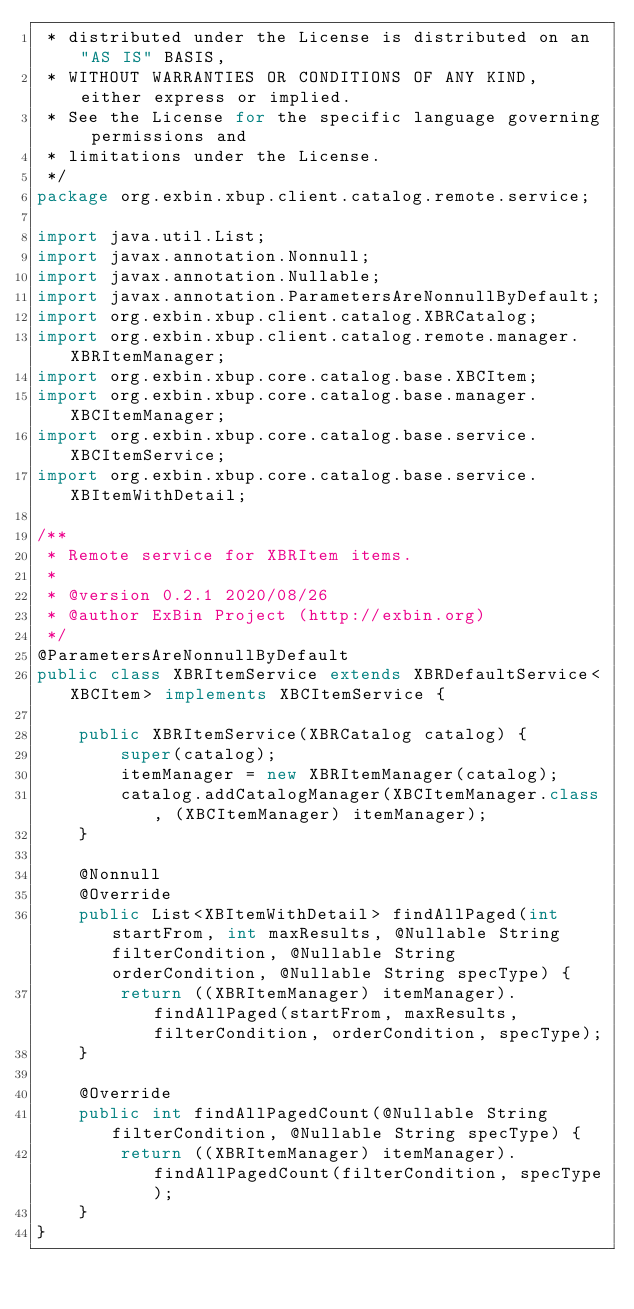<code> <loc_0><loc_0><loc_500><loc_500><_Java_> * distributed under the License is distributed on an "AS IS" BASIS,
 * WITHOUT WARRANTIES OR CONDITIONS OF ANY KIND, either express or implied.
 * See the License for the specific language governing permissions and
 * limitations under the License.
 */
package org.exbin.xbup.client.catalog.remote.service;

import java.util.List;
import javax.annotation.Nonnull;
import javax.annotation.Nullable;
import javax.annotation.ParametersAreNonnullByDefault;
import org.exbin.xbup.client.catalog.XBRCatalog;
import org.exbin.xbup.client.catalog.remote.manager.XBRItemManager;
import org.exbin.xbup.core.catalog.base.XBCItem;
import org.exbin.xbup.core.catalog.base.manager.XBCItemManager;
import org.exbin.xbup.core.catalog.base.service.XBCItemService;
import org.exbin.xbup.core.catalog.base.service.XBItemWithDetail;

/**
 * Remote service for XBRItem items.
 *
 * @version 0.2.1 2020/08/26
 * @author ExBin Project (http://exbin.org)
 */
@ParametersAreNonnullByDefault
public class XBRItemService extends XBRDefaultService<XBCItem> implements XBCItemService {

    public XBRItemService(XBRCatalog catalog) {
        super(catalog);
        itemManager = new XBRItemManager(catalog);
        catalog.addCatalogManager(XBCItemManager.class, (XBCItemManager) itemManager);
    }

    @Nonnull
    @Override
    public List<XBItemWithDetail> findAllPaged(int startFrom, int maxResults, @Nullable String filterCondition, @Nullable String orderCondition, @Nullable String specType) {
        return ((XBRItemManager) itemManager).findAllPaged(startFrom, maxResults, filterCondition, orderCondition, specType);
    }

    @Override
    public int findAllPagedCount(@Nullable String filterCondition, @Nullable String specType) {
        return ((XBRItemManager) itemManager).findAllPagedCount(filterCondition, specType);
    }
}
</code> 